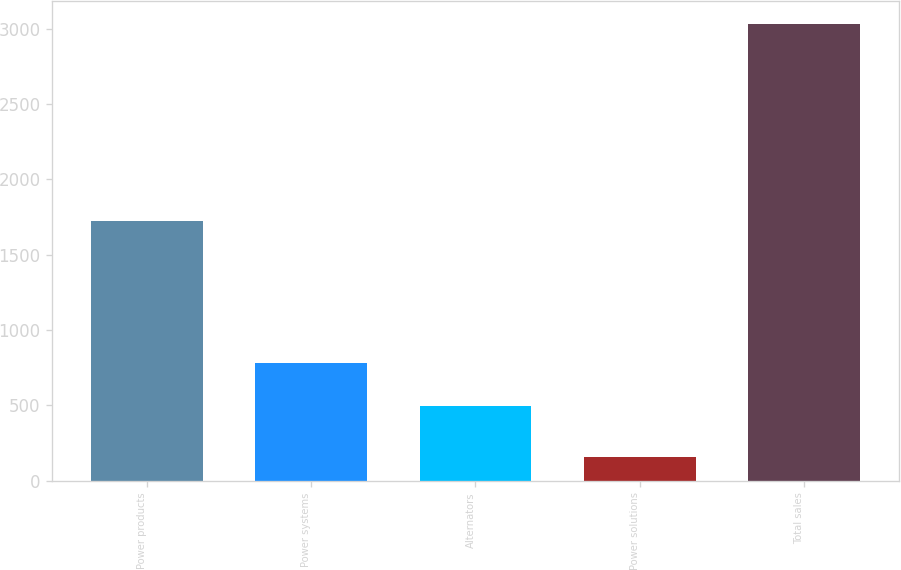Convert chart. <chart><loc_0><loc_0><loc_500><loc_500><bar_chart><fcel>Power products<fcel>Power systems<fcel>Alternators<fcel>Power solutions<fcel>Total sales<nl><fcel>1725<fcel>783.7<fcel>496<fcel>154<fcel>3031<nl></chart> 